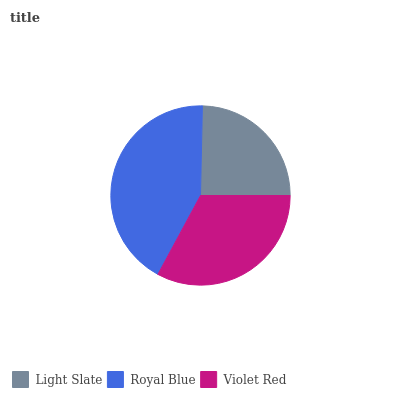Is Light Slate the minimum?
Answer yes or no. Yes. Is Royal Blue the maximum?
Answer yes or no. Yes. Is Violet Red the minimum?
Answer yes or no. No. Is Violet Red the maximum?
Answer yes or no. No. Is Royal Blue greater than Violet Red?
Answer yes or no. Yes. Is Violet Red less than Royal Blue?
Answer yes or no. Yes. Is Violet Red greater than Royal Blue?
Answer yes or no. No. Is Royal Blue less than Violet Red?
Answer yes or no. No. Is Violet Red the high median?
Answer yes or no. Yes. Is Violet Red the low median?
Answer yes or no. Yes. Is Royal Blue the high median?
Answer yes or no. No. Is Royal Blue the low median?
Answer yes or no. No. 